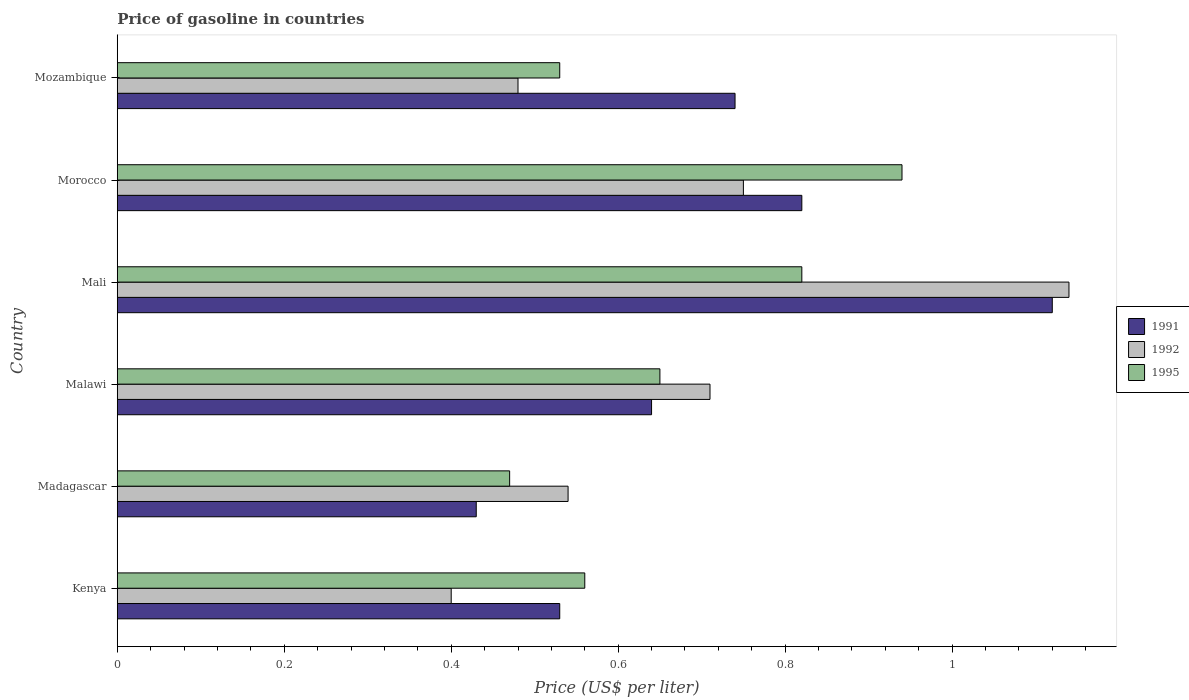Are the number of bars per tick equal to the number of legend labels?
Offer a terse response. Yes. Are the number of bars on each tick of the Y-axis equal?
Your answer should be very brief. Yes. What is the label of the 5th group of bars from the top?
Ensure brevity in your answer.  Madagascar. In how many cases, is the number of bars for a given country not equal to the number of legend labels?
Keep it short and to the point. 0. What is the price of gasoline in 1995 in Mali?
Your answer should be compact. 0.82. Across all countries, what is the maximum price of gasoline in 1992?
Your response must be concise. 1.14. Across all countries, what is the minimum price of gasoline in 1995?
Give a very brief answer. 0.47. In which country was the price of gasoline in 1991 maximum?
Ensure brevity in your answer.  Mali. In which country was the price of gasoline in 1992 minimum?
Offer a terse response. Kenya. What is the total price of gasoline in 1991 in the graph?
Offer a terse response. 4.28. What is the difference between the price of gasoline in 1995 in Madagascar and that in Mozambique?
Provide a short and direct response. -0.06. What is the difference between the price of gasoline in 1991 in Malawi and the price of gasoline in 1992 in Mozambique?
Your answer should be very brief. 0.16. What is the average price of gasoline in 1991 per country?
Your answer should be very brief. 0.71. What is the difference between the price of gasoline in 1991 and price of gasoline in 1995 in Mozambique?
Provide a succinct answer. 0.21. In how many countries, is the price of gasoline in 1992 greater than 0.48000000000000004 US$?
Offer a terse response. 4. What is the ratio of the price of gasoline in 1992 in Madagascar to that in Mali?
Offer a very short reply. 0.47. Is the difference between the price of gasoline in 1991 in Kenya and Mali greater than the difference between the price of gasoline in 1995 in Kenya and Mali?
Give a very brief answer. No. What is the difference between the highest and the second highest price of gasoline in 1991?
Provide a succinct answer. 0.3. What is the difference between the highest and the lowest price of gasoline in 1992?
Offer a very short reply. 0.74. In how many countries, is the price of gasoline in 1992 greater than the average price of gasoline in 1992 taken over all countries?
Offer a terse response. 3. Is the sum of the price of gasoline in 1995 in Mali and Mozambique greater than the maximum price of gasoline in 1991 across all countries?
Keep it short and to the point. Yes. How many bars are there?
Make the answer very short. 18. Are all the bars in the graph horizontal?
Your response must be concise. Yes. Are the values on the major ticks of X-axis written in scientific E-notation?
Ensure brevity in your answer.  No. How many legend labels are there?
Ensure brevity in your answer.  3. How are the legend labels stacked?
Your response must be concise. Vertical. What is the title of the graph?
Give a very brief answer. Price of gasoline in countries. Does "1987" appear as one of the legend labels in the graph?
Give a very brief answer. No. What is the label or title of the X-axis?
Make the answer very short. Price (US$ per liter). What is the Price (US$ per liter) in 1991 in Kenya?
Provide a short and direct response. 0.53. What is the Price (US$ per liter) in 1992 in Kenya?
Offer a very short reply. 0.4. What is the Price (US$ per liter) of 1995 in Kenya?
Give a very brief answer. 0.56. What is the Price (US$ per liter) of 1991 in Madagascar?
Keep it short and to the point. 0.43. What is the Price (US$ per liter) of 1992 in Madagascar?
Your answer should be compact. 0.54. What is the Price (US$ per liter) of 1995 in Madagascar?
Make the answer very short. 0.47. What is the Price (US$ per liter) in 1991 in Malawi?
Offer a very short reply. 0.64. What is the Price (US$ per liter) of 1992 in Malawi?
Give a very brief answer. 0.71. What is the Price (US$ per liter) of 1995 in Malawi?
Provide a short and direct response. 0.65. What is the Price (US$ per liter) in 1991 in Mali?
Offer a very short reply. 1.12. What is the Price (US$ per liter) in 1992 in Mali?
Provide a succinct answer. 1.14. What is the Price (US$ per liter) in 1995 in Mali?
Keep it short and to the point. 0.82. What is the Price (US$ per liter) of 1991 in Morocco?
Give a very brief answer. 0.82. What is the Price (US$ per liter) of 1992 in Morocco?
Offer a terse response. 0.75. What is the Price (US$ per liter) of 1995 in Morocco?
Offer a very short reply. 0.94. What is the Price (US$ per liter) in 1991 in Mozambique?
Your response must be concise. 0.74. What is the Price (US$ per liter) in 1992 in Mozambique?
Keep it short and to the point. 0.48. What is the Price (US$ per liter) in 1995 in Mozambique?
Offer a very short reply. 0.53. Across all countries, what is the maximum Price (US$ per liter) of 1991?
Give a very brief answer. 1.12. Across all countries, what is the maximum Price (US$ per liter) in 1992?
Offer a terse response. 1.14. Across all countries, what is the minimum Price (US$ per liter) of 1991?
Give a very brief answer. 0.43. Across all countries, what is the minimum Price (US$ per liter) in 1992?
Your answer should be compact. 0.4. Across all countries, what is the minimum Price (US$ per liter) of 1995?
Make the answer very short. 0.47. What is the total Price (US$ per liter) of 1991 in the graph?
Provide a succinct answer. 4.28. What is the total Price (US$ per liter) of 1992 in the graph?
Make the answer very short. 4.02. What is the total Price (US$ per liter) of 1995 in the graph?
Give a very brief answer. 3.97. What is the difference between the Price (US$ per liter) of 1991 in Kenya and that in Madagascar?
Offer a terse response. 0.1. What is the difference between the Price (US$ per liter) of 1992 in Kenya and that in Madagascar?
Your answer should be compact. -0.14. What is the difference between the Price (US$ per liter) of 1995 in Kenya and that in Madagascar?
Keep it short and to the point. 0.09. What is the difference between the Price (US$ per liter) in 1991 in Kenya and that in Malawi?
Your answer should be compact. -0.11. What is the difference between the Price (US$ per liter) of 1992 in Kenya and that in Malawi?
Ensure brevity in your answer.  -0.31. What is the difference between the Price (US$ per liter) in 1995 in Kenya and that in Malawi?
Make the answer very short. -0.09. What is the difference between the Price (US$ per liter) in 1991 in Kenya and that in Mali?
Keep it short and to the point. -0.59. What is the difference between the Price (US$ per liter) in 1992 in Kenya and that in Mali?
Offer a terse response. -0.74. What is the difference between the Price (US$ per liter) in 1995 in Kenya and that in Mali?
Give a very brief answer. -0.26. What is the difference between the Price (US$ per liter) in 1991 in Kenya and that in Morocco?
Your answer should be compact. -0.29. What is the difference between the Price (US$ per liter) in 1992 in Kenya and that in Morocco?
Offer a terse response. -0.35. What is the difference between the Price (US$ per liter) of 1995 in Kenya and that in Morocco?
Your answer should be very brief. -0.38. What is the difference between the Price (US$ per liter) of 1991 in Kenya and that in Mozambique?
Offer a very short reply. -0.21. What is the difference between the Price (US$ per liter) of 1992 in Kenya and that in Mozambique?
Give a very brief answer. -0.08. What is the difference between the Price (US$ per liter) in 1995 in Kenya and that in Mozambique?
Offer a terse response. 0.03. What is the difference between the Price (US$ per liter) in 1991 in Madagascar and that in Malawi?
Provide a succinct answer. -0.21. What is the difference between the Price (US$ per liter) of 1992 in Madagascar and that in Malawi?
Your response must be concise. -0.17. What is the difference between the Price (US$ per liter) of 1995 in Madagascar and that in Malawi?
Give a very brief answer. -0.18. What is the difference between the Price (US$ per liter) of 1991 in Madagascar and that in Mali?
Your answer should be compact. -0.69. What is the difference between the Price (US$ per liter) of 1995 in Madagascar and that in Mali?
Your response must be concise. -0.35. What is the difference between the Price (US$ per liter) in 1991 in Madagascar and that in Morocco?
Provide a short and direct response. -0.39. What is the difference between the Price (US$ per liter) in 1992 in Madagascar and that in Morocco?
Your answer should be very brief. -0.21. What is the difference between the Price (US$ per liter) of 1995 in Madagascar and that in Morocco?
Keep it short and to the point. -0.47. What is the difference between the Price (US$ per liter) in 1991 in Madagascar and that in Mozambique?
Provide a succinct answer. -0.31. What is the difference between the Price (US$ per liter) in 1992 in Madagascar and that in Mozambique?
Offer a terse response. 0.06. What is the difference between the Price (US$ per liter) of 1995 in Madagascar and that in Mozambique?
Give a very brief answer. -0.06. What is the difference between the Price (US$ per liter) of 1991 in Malawi and that in Mali?
Provide a succinct answer. -0.48. What is the difference between the Price (US$ per liter) in 1992 in Malawi and that in Mali?
Your answer should be compact. -0.43. What is the difference between the Price (US$ per liter) of 1995 in Malawi and that in Mali?
Ensure brevity in your answer.  -0.17. What is the difference between the Price (US$ per liter) in 1991 in Malawi and that in Morocco?
Provide a succinct answer. -0.18. What is the difference between the Price (US$ per liter) in 1992 in Malawi and that in Morocco?
Provide a short and direct response. -0.04. What is the difference between the Price (US$ per liter) of 1995 in Malawi and that in Morocco?
Your answer should be very brief. -0.29. What is the difference between the Price (US$ per liter) in 1992 in Malawi and that in Mozambique?
Keep it short and to the point. 0.23. What is the difference between the Price (US$ per liter) in 1995 in Malawi and that in Mozambique?
Ensure brevity in your answer.  0.12. What is the difference between the Price (US$ per liter) in 1992 in Mali and that in Morocco?
Ensure brevity in your answer.  0.39. What is the difference between the Price (US$ per liter) of 1995 in Mali and that in Morocco?
Make the answer very short. -0.12. What is the difference between the Price (US$ per liter) in 1991 in Mali and that in Mozambique?
Your answer should be very brief. 0.38. What is the difference between the Price (US$ per liter) in 1992 in Mali and that in Mozambique?
Offer a very short reply. 0.66. What is the difference between the Price (US$ per liter) in 1995 in Mali and that in Mozambique?
Offer a very short reply. 0.29. What is the difference between the Price (US$ per liter) in 1992 in Morocco and that in Mozambique?
Ensure brevity in your answer.  0.27. What is the difference between the Price (US$ per liter) in 1995 in Morocco and that in Mozambique?
Your response must be concise. 0.41. What is the difference between the Price (US$ per liter) in 1991 in Kenya and the Price (US$ per liter) in 1992 in Madagascar?
Your answer should be compact. -0.01. What is the difference between the Price (US$ per liter) of 1991 in Kenya and the Price (US$ per liter) of 1995 in Madagascar?
Give a very brief answer. 0.06. What is the difference between the Price (US$ per liter) in 1992 in Kenya and the Price (US$ per liter) in 1995 in Madagascar?
Offer a terse response. -0.07. What is the difference between the Price (US$ per liter) of 1991 in Kenya and the Price (US$ per liter) of 1992 in Malawi?
Provide a succinct answer. -0.18. What is the difference between the Price (US$ per liter) of 1991 in Kenya and the Price (US$ per liter) of 1995 in Malawi?
Your answer should be compact. -0.12. What is the difference between the Price (US$ per liter) in 1991 in Kenya and the Price (US$ per liter) in 1992 in Mali?
Provide a succinct answer. -0.61. What is the difference between the Price (US$ per liter) in 1991 in Kenya and the Price (US$ per liter) in 1995 in Mali?
Offer a very short reply. -0.29. What is the difference between the Price (US$ per liter) in 1992 in Kenya and the Price (US$ per liter) in 1995 in Mali?
Your answer should be very brief. -0.42. What is the difference between the Price (US$ per liter) of 1991 in Kenya and the Price (US$ per liter) of 1992 in Morocco?
Make the answer very short. -0.22. What is the difference between the Price (US$ per liter) of 1991 in Kenya and the Price (US$ per liter) of 1995 in Morocco?
Offer a very short reply. -0.41. What is the difference between the Price (US$ per liter) in 1992 in Kenya and the Price (US$ per liter) in 1995 in Morocco?
Your answer should be compact. -0.54. What is the difference between the Price (US$ per liter) of 1991 in Kenya and the Price (US$ per liter) of 1992 in Mozambique?
Your answer should be compact. 0.05. What is the difference between the Price (US$ per liter) in 1991 in Kenya and the Price (US$ per liter) in 1995 in Mozambique?
Keep it short and to the point. 0. What is the difference between the Price (US$ per liter) of 1992 in Kenya and the Price (US$ per liter) of 1995 in Mozambique?
Offer a terse response. -0.13. What is the difference between the Price (US$ per liter) of 1991 in Madagascar and the Price (US$ per liter) of 1992 in Malawi?
Provide a succinct answer. -0.28. What is the difference between the Price (US$ per liter) in 1991 in Madagascar and the Price (US$ per liter) in 1995 in Malawi?
Your answer should be very brief. -0.22. What is the difference between the Price (US$ per liter) in 1992 in Madagascar and the Price (US$ per liter) in 1995 in Malawi?
Your answer should be compact. -0.11. What is the difference between the Price (US$ per liter) of 1991 in Madagascar and the Price (US$ per liter) of 1992 in Mali?
Provide a short and direct response. -0.71. What is the difference between the Price (US$ per liter) of 1991 in Madagascar and the Price (US$ per liter) of 1995 in Mali?
Your response must be concise. -0.39. What is the difference between the Price (US$ per liter) in 1992 in Madagascar and the Price (US$ per liter) in 1995 in Mali?
Give a very brief answer. -0.28. What is the difference between the Price (US$ per liter) in 1991 in Madagascar and the Price (US$ per liter) in 1992 in Morocco?
Offer a very short reply. -0.32. What is the difference between the Price (US$ per liter) in 1991 in Madagascar and the Price (US$ per liter) in 1995 in Morocco?
Make the answer very short. -0.51. What is the difference between the Price (US$ per liter) of 1991 in Madagascar and the Price (US$ per liter) of 1995 in Mozambique?
Offer a terse response. -0.1. What is the difference between the Price (US$ per liter) of 1991 in Malawi and the Price (US$ per liter) of 1995 in Mali?
Offer a very short reply. -0.18. What is the difference between the Price (US$ per liter) in 1992 in Malawi and the Price (US$ per liter) in 1995 in Mali?
Provide a succinct answer. -0.11. What is the difference between the Price (US$ per liter) in 1991 in Malawi and the Price (US$ per liter) in 1992 in Morocco?
Your answer should be compact. -0.11. What is the difference between the Price (US$ per liter) of 1991 in Malawi and the Price (US$ per liter) of 1995 in Morocco?
Provide a short and direct response. -0.3. What is the difference between the Price (US$ per liter) of 1992 in Malawi and the Price (US$ per liter) of 1995 in Morocco?
Ensure brevity in your answer.  -0.23. What is the difference between the Price (US$ per liter) in 1991 in Malawi and the Price (US$ per liter) in 1992 in Mozambique?
Keep it short and to the point. 0.16. What is the difference between the Price (US$ per liter) of 1991 in Malawi and the Price (US$ per liter) of 1995 in Mozambique?
Ensure brevity in your answer.  0.11. What is the difference between the Price (US$ per liter) in 1992 in Malawi and the Price (US$ per liter) in 1995 in Mozambique?
Your answer should be very brief. 0.18. What is the difference between the Price (US$ per liter) in 1991 in Mali and the Price (US$ per liter) in 1992 in Morocco?
Keep it short and to the point. 0.37. What is the difference between the Price (US$ per liter) in 1991 in Mali and the Price (US$ per liter) in 1995 in Morocco?
Provide a short and direct response. 0.18. What is the difference between the Price (US$ per liter) of 1992 in Mali and the Price (US$ per liter) of 1995 in Morocco?
Provide a short and direct response. 0.2. What is the difference between the Price (US$ per liter) in 1991 in Mali and the Price (US$ per liter) in 1992 in Mozambique?
Ensure brevity in your answer.  0.64. What is the difference between the Price (US$ per liter) in 1991 in Mali and the Price (US$ per liter) in 1995 in Mozambique?
Keep it short and to the point. 0.59. What is the difference between the Price (US$ per liter) of 1992 in Mali and the Price (US$ per liter) of 1995 in Mozambique?
Provide a short and direct response. 0.61. What is the difference between the Price (US$ per liter) of 1991 in Morocco and the Price (US$ per liter) of 1992 in Mozambique?
Provide a short and direct response. 0.34. What is the difference between the Price (US$ per liter) of 1991 in Morocco and the Price (US$ per liter) of 1995 in Mozambique?
Give a very brief answer. 0.29. What is the difference between the Price (US$ per liter) of 1992 in Morocco and the Price (US$ per liter) of 1995 in Mozambique?
Provide a succinct answer. 0.22. What is the average Price (US$ per liter) of 1991 per country?
Your answer should be very brief. 0.71. What is the average Price (US$ per liter) of 1992 per country?
Offer a very short reply. 0.67. What is the average Price (US$ per liter) of 1995 per country?
Provide a succinct answer. 0.66. What is the difference between the Price (US$ per liter) of 1991 and Price (US$ per liter) of 1992 in Kenya?
Ensure brevity in your answer.  0.13. What is the difference between the Price (US$ per liter) of 1991 and Price (US$ per liter) of 1995 in Kenya?
Give a very brief answer. -0.03. What is the difference between the Price (US$ per liter) in 1992 and Price (US$ per liter) in 1995 in Kenya?
Give a very brief answer. -0.16. What is the difference between the Price (US$ per liter) in 1991 and Price (US$ per liter) in 1992 in Madagascar?
Make the answer very short. -0.11. What is the difference between the Price (US$ per liter) of 1991 and Price (US$ per liter) of 1995 in Madagascar?
Keep it short and to the point. -0.04. What is the difference between the Price (US$ per liter) in 1992 and Price (US$ per liter) in 1995 in Madagascar?
Your answer should be very brief. 0.07. What is the difference between the Price (US$ per liter) in 1991 and Price (US$ per liter) in 1992 in Malawi?
Offer a terse response. -0.07. What is the difference between the Price (US$ per liter) of 1991 and Price (US$ per liter) of 1995 in Malawi?
Your response must be concise. -0.01. What is the difference between the Price (US$ per liter) in 1991 and Price (US$ per liter) in 1992 in Mali?
Give a very brief answer. -0.02. What is the difference between the Price (US$ per liter) in 1991 and Price (US$ per liter) in 1995 in Mali?
Provide a short and direct response. 0.3. What is the difference between the Price (US$ per liter) in 1992 and Price (US$ per liter) in 1995 in Mali?
Make the answer very short. 0.32. What is the difference between the Price (US$ per liter) in 1991 and Price (US$ per liter) in 1992 in Morocco?
Provide a short and direct response. 0.07. What is the difference between the Price (US$ per liter) in 1991 and Price (US$ per liter) in 1995 in Morocco?
Your answer should be compact. -0.12. What is the difference between the Price (US$ per liter) of 1992 and Price (US$ per liter) of 1995 in Morocco?
Make the answer very short. -0.19. What is the difference between the Price (US$ per liter) in 1991 and Price (US$ per liter) in 1992 in Mozambique?
Make the answer very short. 0.26. What is the difference between the Price (US$ per liter) of 1991 and Price (US$ per liter) of 1995 in Mozambique?
Offer a very short reply. 0.21. What is the ratio of the Price (US$ per liter) of 1991 in Kenya to that in Madagascar?
Offer a terse response. 1.23. What is the ratio of the Price (US$ per liter) in 1992 in Kenya to that in Madagascar?
Offer a very short reply. 0.74. What is the ratio of the Price (US$ per liter) in 1995 in Kenya to that in Madagascar?
Your response must be concise. 1.19. What is the ratio of the Price (US$ per liter) in 1991 in Kenya to that in Malawi?
Offer a terse response. 0.83. What is the ratio of the Price (US$ per liter) in 1992 in Kenya to that in Malawi?
Offer a very short reply. 0.56. What is the ratio of the Price (US$ per liter) in 1995 in Kenya to that in Malawi?
Keep it short and to the point. 0.86. What is the ratio of the Price (US$ per liter) of 1991 in Kenya to that in Mali?
Your answer should be very brief. 0.47. What is the ratio of the Price (US$ per liter) of 1992 in Kenya to that in Mali?
Provide a short and direct response. 0.35. What is the ratio of the Price (US$ per liter) of 1995 in Kenya to that in Mali?
Offer a very short reply. 0.68. What is the ratio of the Price (US$ per liter) of 1991 in Kenya to that in Morocco?
Make the answer very short. 0.65. What is the ratio of the Price (US$ per liter) of 1992 in Kenya to that in Morocco?
Provide a short and direct response. 0.53. What is the ratio of the Price (US$ per liter) in 1995 in Kenya to that in Morocco?
Ensure brevity in your answer.  0.6. What is the ratio of the Price (US$ per liter) in 1991 in Kenya to that in Mozambique?
Offer a very short reply. 0.72. What is the ratio of the Price (US$ per liter) of 1992 in Kenya to that in Mozambique?
Give a very brief answer. 0.83. What is the ratio of the Price (US$ per liter) in 1995 in Kenya to that in Mozambique?
Your answer should be very brief. 1.06. What is the ratio of the Price (US$ per liter) of 1991 in Madagascar to that in Malawi?
Provide a succinct answer. 0.67. What is the ratio of the Price (US$ per liter) of 1992 in Madagascar to that in Malawi?
Provide a short and direct response. 0.76. What is the ratio of the Price (US$ per liter) in 1995 in Madagascar to that in Malawi?
Offer a terse response. 0.72. What is the ratio of the Price (US$ per liter) of 1991 in Madagascar to that in Mali?
Ensure brevity in your answer.  0.38. What is the ratio of the Price (US$ per liter) of 1992 in Madagascar to that in Mali?
Provide a short and direct response. 0.47. What is the ratio of the Price (US$ per liter) in 1995 in Madagascar to that in Mali?
Make the answer very short. 0.57. What is the ratio of the Price (US$ per liter) of 1991 in Madagascar to that in Morocco?
Provide a succinct answer. 0.52. What is the ratio of the Price (US$ per liter) of 1992 in Madagascar to that in Morocco?
Make the answer very short. 0.72. What is the ratio of the Price (US$ per liter) in 1991 in Madagascar to that in Mozambique?
Keep it short and to the point. 0.58. What is the ratio of the Price (US$ per liter) of 1992 in Madagascar to that in Mozambique?
Provide a succinct answer. 1.12. What is the ratio of the Price (US$ per liter) in 1995 in Madagascar to that in Mozambique?
Ensure brevity in your answer.  0.89. What is the ratio of the Price (US$ per liter) of 1992 in Malawi to that in Mali?
Your response must be concise. 0.62. What is the ratio of the Price (US$ per liter) in 1995 in Malawi to that in Mali?
Offer a terse response. 0.79. What is the ratio of the Price (US$ per liter) in 1991 in Malawi to that in Morocco?
Your answer should be compact. 0.78. What is the ratio of the Price (US$ per liter) of 1992 in Malawi to that in Morocco?
Offer a very short reply. 0.95. What is the ratio of the Price (US$ per liter) in 1995 in Malawi to that in Morocco?
Provide a succinct answer. 0.69. What is the ratio of the Price (US$ per liter) of 1991 in Malawi to that in Mozambique?
Keep it short and to the point. 0.86. What is the ratio of the Price (US$ per liter) of 1992 in Malawi to that in Mozambique?
Make the answer very short. 1.48. What is the ratio of the Price (US$ per liter) of 1995 in Malawi to that in Mozambique?
Offer a very short reply. 1.23. What is the ratio of the Price (US$ per liter) of 1991 in Mali to that in Morocco?
Provide a short and direct response. 1.37. What is the ratio of the Price (US$ per liter) of 1992 in Mali to that in Morocco?
Your response must be concise. 1.52. What is the ratio of the Price (US$ per liter) of 1995 in Mali to that in Morocco?
Offer a terse response. 0.87. What is the ratio of the Price (US$ per liter) of 1991 in Mali to that in Mozambique?
Give a very brief answer. 1.51. What is the ratio of the Price (US$ per liter) of 1992 in Mali to that in Mozambique?
Provide a succinct answer. 2.38. What is the ratio of the Price (US$ per liter) in 1995 in Mali to that in Mozambique?
Your answer should be very brief. 1.55. What is the ratio of the Price (US$ per liter) in 1991 in Morocco to that in Mozambique?
Ensure brevity in your answer.  1.11. What is the ratio of the Price (US$ per liter) in 1992 in Morocco to that in Mozambique?
Offer a terse response. 1.56. What is the ratio of the Price (US$ per liter) of 1995 in Morocco to that in Mozambique?
Offer a very short reply. 1.77. What is the difference between the highest and the second highest Price (US$ per liter) in 1991?
Your answer should be compact. 0.3. What is the difference between the highest and the second highest Price (US$ per liter) of 1992?
Offer a terse response. 0.39. What is the difference between the highest and the second highest Price (US$ per liter) in 1995?
Ensure brevity in your answer.  0.12. What is the difference between the highest and the lowest Price (US$ per liter) of 1991?
Make the answer very short. 0.69. What is the difference between the highest and the lowest Price (US$ per liter) in 1992?
Offer a terse response. 0.74. What is the difference between the highest and the lowest Price (US$ per liter) of 1995?
Make the answer very short. 0.47. 